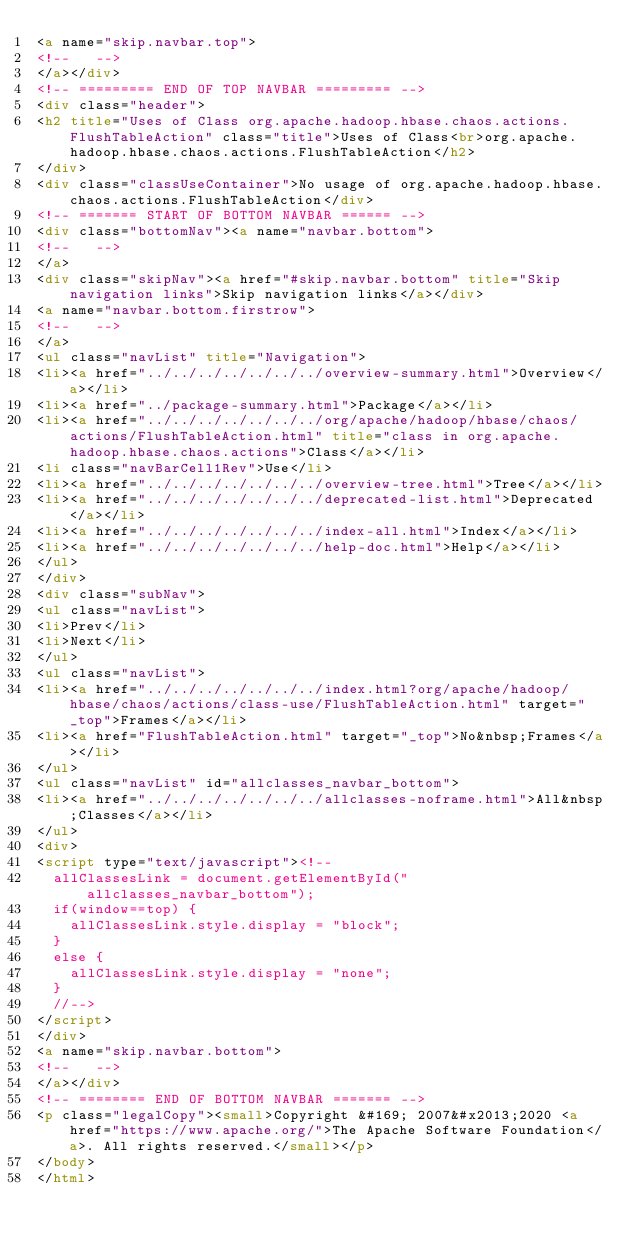<code> <loc_0><loc_0><loc_500><loc_500><_HTML_><a name="skip.navbar.top">
<!--   -->
</a></div>
<!-- ========= END OF TOP NAVBAR ========= -->
<div class="header">
<h2 title="Uses of Class org.apache.hadoop.hbase.chaos.actions.FlushTableAction" class="title">Uses of Class<br>org.apache.hadoop.hbase.chaos.actions.FlushTableAction</h2>
</div>
<div class="classUseContainer">No usage of org.apache.hadoop.hbase.chaos.actions.FlushTableAction</div>
<!-- ======= START OF BOTTOM NAVBAR ====== -->
<div class="bottomNav"><a name="navbar.bottom">
<!--   -->
</a>
<div class="skipNav"><a href="#skip.navbar.bottom" title="Skip navigation links">Skip navigation links</a></div>
<a name="navbar.bottom.firstrow">
<!--   -->
</a>
<ul class="navList" title="Navigation">
<li><a href="../../../../../../../overview-summary.html">Overview</a></li>
<li><a href="../package-summary.html">Package</a></li>
<li><a href="../../../../../../../org/apache/hadoop/hbase/chaos/actions/FlushTableAction.html" title="class in org.apache.hadoop.hbase.chaos.actions">Class</a></li>
<li class="navBarCell1Rev">Use</li>
<li><a href="../../../../../../../overview-tree.html">Tree</a></li>
<li><a href="../../../../../../../deprecated-list.html">Deprecated</a></li>
<li><a href="../../../../../../../index-all.html">Index</a></li>
<li><a href="../../../../../../../help-doc.html">Help</a></li>
</ul>
</div>
<div class="subNav">
<ul class="navList">
<li>Prev</li>
<li>Next</li>
</ul>
<ul class="navList">
<li><a href="../../../../../../../index.html?org/apache/hadoop/hbase/chaos/actions/class-use/FlushTableAction.html" target="_top">Frames</a></li>
<li><a href="FlushTableAction.html" target="_top">No&nbsp;Frames</a></li>
</ul>
<ul class="navList" id="allclasses_navbar_bottom">
<li><a href="../../../../../../../allclasses-noframe.html">All&nbsp;Classes</a></li>
</ul>
<div>
<script type="text/javascript"><!--
  allClassesLink = document.getElementById("allclasses_navbar_bottom");
  if(window==top) {
    allClassesLink.style.display = "block";
  }
  else {
    allClassesLink.style.display = "none";
  }
  //-->
</script>
</div>
<a name="skip.navbar.bottom">
<!--   -->
</a></div>
<!-- ======== END OF BOTTOM NAVBAR ======= -->
<p class="legalCopy"><small>Copyright &#169; 2007&#x2013;2020 <a href="https://www.apache.org/">The Apache Software Foundation</a>. All rights reserved.</small></p>
</body>
</html>
</code> 